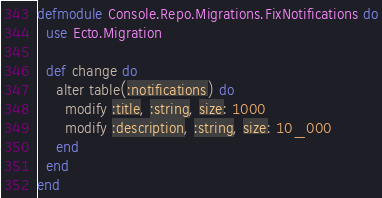Convert code to text. <code><loc_0><loc_0><loc_500><loc_500><_Elixir_>defmodule Console.Repo.Migrations.FixNotifications do
  use Ecto.Migration

  def change do
    alter table(:notifications) do
      modify :title, :string, size: 1000
      modify :description, :string, size: 10_000
    end
  end
end
</code> 